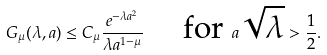Convert formula to latex. <formula><loc_0><loc_0><loc_500><loc_500>G _ { \mu } ( \lambda , a ) \leq C _ { \mu } \frac { e ^ { - \lambda a ^ { 2 } } } { \lambda a ^ { 1 - \mu } } \quad \text { for   } a \sqrt { \lambda } > \frac { 1 } { 2 } .</formula> 